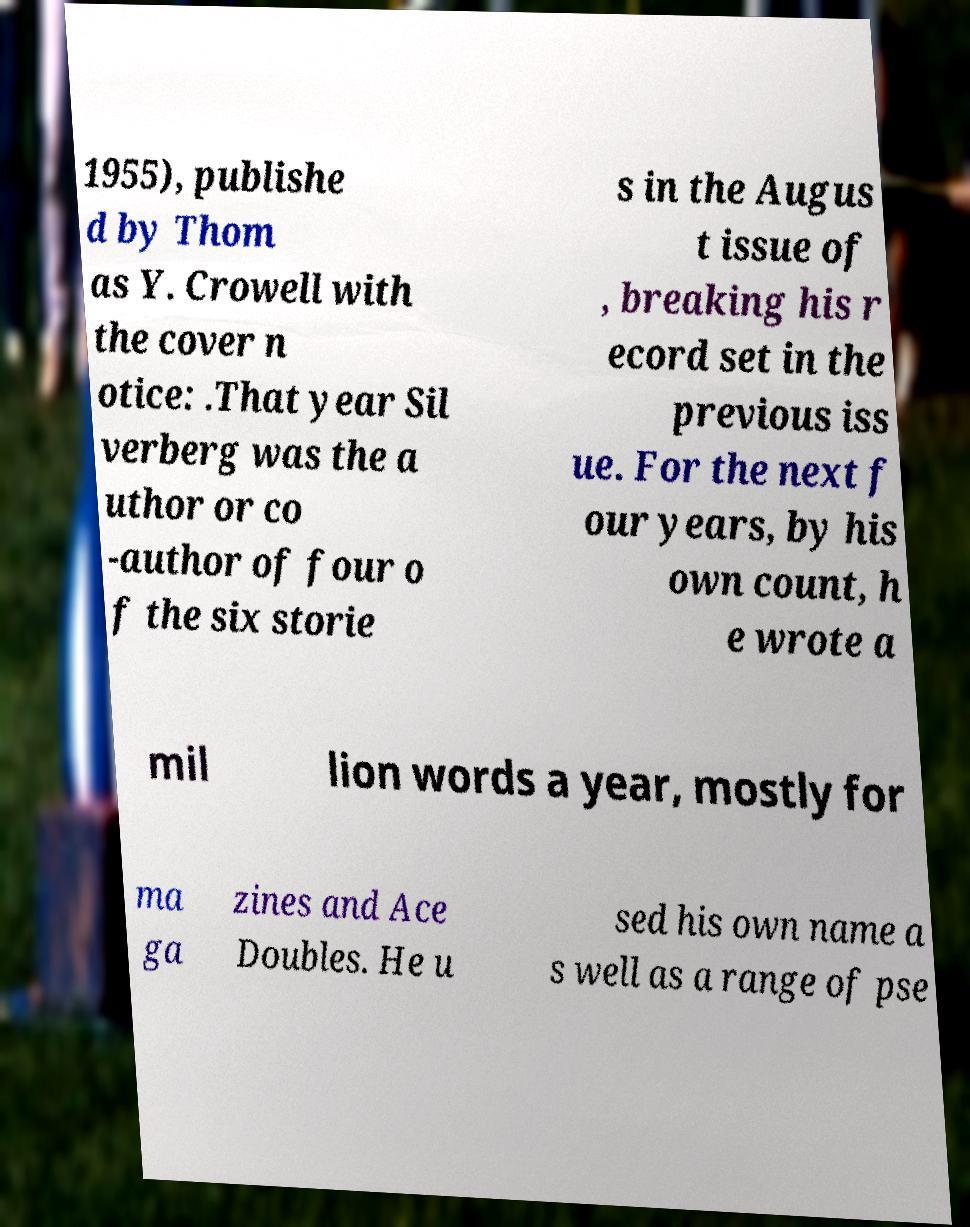Can you read and provide the text displayed in the image?This photo seems to have some interesting text. Can you extract and type it out for me? 1955), publishe d by Thom as Y. Crowell with the cover n otice: .That year Sil verberg was the a uthor or co -author of four o f the six storie s in the Augus t issue of , breaking his r ecord set in the previous iss ue. For the next f our years, by his own count, h e wrote a mil lion words a year, mostly for ma ga zines and Ace Doubles. He u sed his own name a s well as a range of pse 